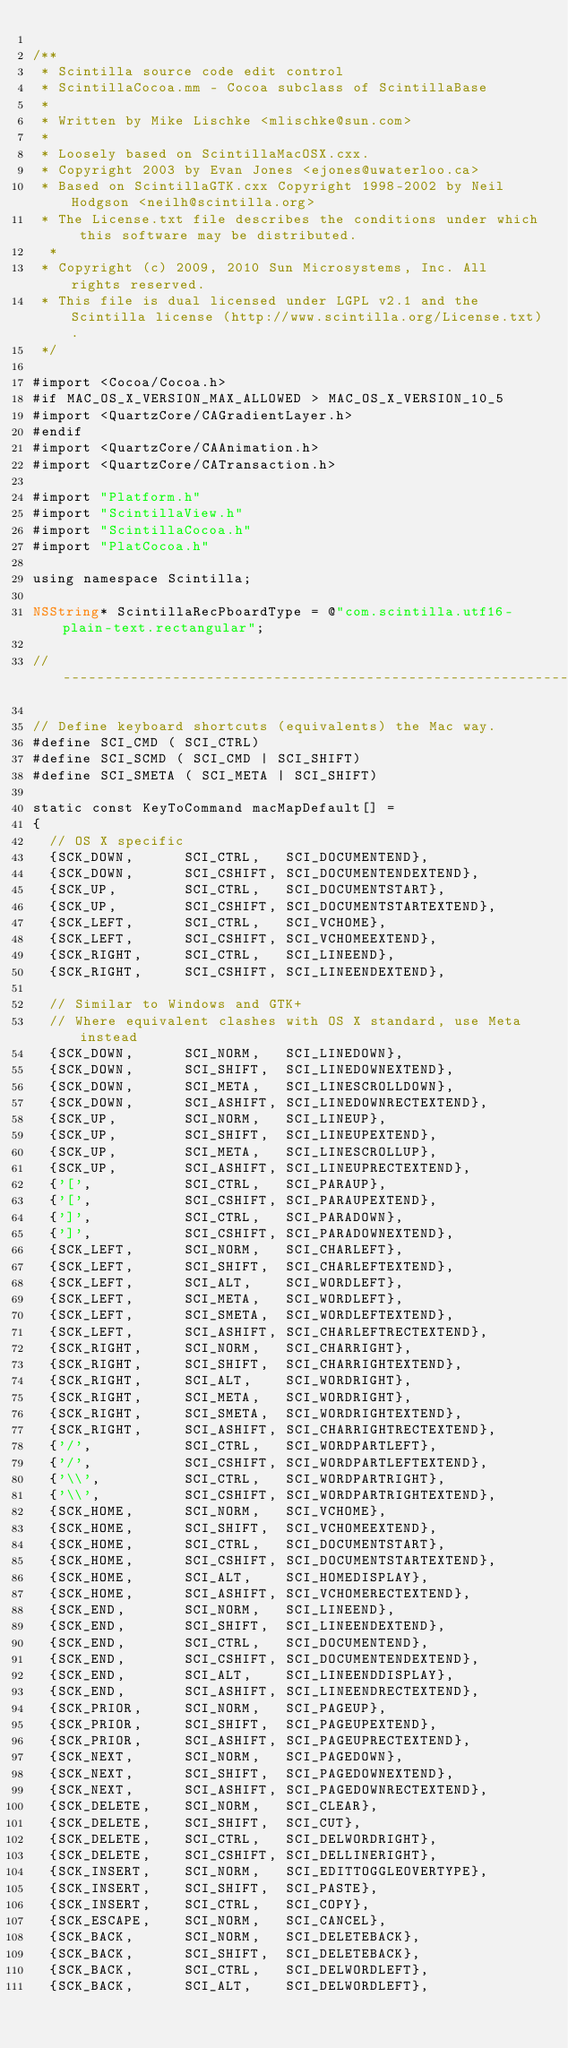<code> <loc_0><loc_0><loc_500><loc_500><_ObjectiveC_>
/**
 * Scintilla source code edit control
 * ScintillaCocoa.mm - Cocoa subclass of ScintillaBase
 *
 * Written by Mike Lischke <mlischke@sun.com>
 *
 * Loosely based on ScintillaMacOSX.cxx.
 * Copyright 2003 by Evan Jones <ejones@uwaterloo.ca>
 * Based on ScintillaGTK.cxx Copyright 1998-2002 by Neil Hodgson <neilh@scintilla.org>
 * The License.txt file describes the conditions under which this software may be distributed.
  *
 * Copyright (c) 2009, 2010 Sun Microsystems, Inc. All rights reserved.
 * This file is dual licensed under LGPL v2.1 and the Scintilla license (http://www.scintilla.org/License.txt).
 */

#import <Cocoa/Cocoa.h>
#if MAC_OS_X_VERSION_MAX_ALLOWED > MAC_OS_X_VERSION_10_5
#import <QuartzCore/CAGradientLayer.h>
#endif
#import <QuartzCore/CAAnimation.h>
#import <QuartzCore/CATransaction.h>

#import "Platform.h"
#import "ScintillaView.h"
#import "ScintillaCocoa.h"
#import "PlatCocoa.h"

using namespace Scintilla;

NSString* ScintillaRecPboardType = @"com.scintilla.utf16-plain-text.rectangular";

//--------------------------------------------------------------------------------------------------

// Define keyboard shortcuts (equivalents) the Mac way.
#define SCI_CMD ( SCI_CTRL)
#define SCI_SCMD ( SCI_CMD | SCI_SHIFT)
#define SCI_SMETA ( SCI_META | SCI_SHIFT)

static const KeyToCommand macMapDefault[] =
{
  // OS X specific
  {SCK_DOWN,      SCI_CTRL,   SCI_DOCUMENTEND},
  {SCK_DOWN,      SCI_CSHIFT, SCI_DOCUMENTENDEXTEND},
  {SCK_UP,        SCI_CTRL,   SCI_DOCUMENTSTART},
  {SCK_UP,        SCI_CSHIFT, SCI_DOCUMENTSTARTEXTEND},
  {SCK_LEFT,      SCI_CTRL,   SCI_VCHOME},
  {SCK_LEFT,      SCI_CSHIFT, SCI_VCHOMEEXTEND},
  {SCK_RIGHT,     SCI_CTRL,   SCI_LINEEND},
  {SCK_RIGHT,     SCI_CSHIFT, SCI_LINEENDEXTEND},

  // Similar to Windows and GTK+
  // Where equivalent clashes with OS X standard, use Meta instead
  {SCK_DOWN,      SCI_NORM,   SCI_LINEDOWN},
  {SCK_DOWN,      SCI_SHIFT,  SCI_LINEDOWNEXTEND},
  {SCK_DOWN,      SCI_META,   SCI_LINESCROLLDOWN},
  {SCK_DOWN,      SCI_ASHIFT, SCI_LINEDOWNRECTEXTEND},
  {SCK_UP,        SCI_NORM,   SCI_LINEUP},
  {SCK_UP,        SCI_SHIFT,  SCI_LINEUPEXTEND},
  {SCK_UP,        SCI_META,   SCI_LINESCROLLUP},
  {SCK_UP,        SCI_ASHIFT, SCI_LINEUPRECTEXTEND},
  {'[',           SCI_CTRL,   SCI_PARAUP},
  {'[',           SCI_CSHIFT, SCI_PARAUPEXTEND},
  {']',           SCI_CTRL,   SCI_PARADOWN},
  {']',           SCI_CSHIFT, SCI_PARADOWNEXTEND},
  {SCK_LEFT,      SCI_NORM,   SCI_CHARLEFT},
  {SCK_LEFT,      SCI_SHIFT,  SCI_CHARLEFTEXTEND},
  {SCK_LEFT,      SCI_ALT,    SCI_WORDLEFT},
  {SCK_LEFT,      SCI_META,   SCI_WORDLEFT},
  {SCK_LEFT,      SCI_SMETA,  SCI_WORDLEFTEXTEND},
  {SCK_LEFT,      SCI_ASHIFT, SCI_CHARLEFTRECTEXTEND},
  {SCK_RIGHT,     SCI_NORM,   SCI_CHARRIGHT},
  {SCK_RIGHT,     SCI_SHIFT,  SCI_CHARRIGHTEXTEND},
  {SCK_RIGHT,     SCI_ALT,    SCI_WORDRIGHT},
  {SCK_RIGHT,     SCI_META,   SCI_WORDRIGHT},
  {SCK_RIGHT,     SCI_SMETA,  SCI_WORDRIGHTEXTEND},
  {SCK_RIGHT,     SCI_ASHIFT, SCI_CHARRIGHTRECTEXTEND},
  {'/',           SCI_CTRL,   SCI_WORDPARTLEFT},
  {'/',           SCI_CSHIFT, SCI_WORDPARTLEFTEXTEND},
  {'\\',          SCI_CTRL,   SCI_WORDPARTRIGHT},
  {'\\',          SCI_CSHIFT, SCI_WORDPARTRIGHTEXTEND},
  {SCK_HOME,      SCI_NORM,   SCI_VCHOME},
  {SCK_HOME,      SCI_SHIFT,  SCI_VCHOMEEXTEND},
  {SCK_HOME,      SCI_CTRL,   SCI_DOCUMENTSTART},
  {SCK_HOME,      SCI_CSHIFT, SCI_DOCUMENTSTARTEXTEND},
  {SCK_HOME,      SCI_ALT,    SCI_HOMEDISPLAY},
  {SCK_HOME,      SCI_ASHIFT, SCI_VCHOMERECTEXTEND},
  {SCK_END,       SCI_NORM,   SCI_LINEEND},
  {SCK_END,       SCI_SHIFT,  SCI_LINEENDEXTEND},
  {SCK_END,       SCI_CTRL,   SCI_DOCUMENTEND},
  {SCK_END,       SCI_CSHIFT, SCI_DOCUMENTENDEXTEND},
  {SCK_END,       SCI_ALT,    SCI_LINEENDDISPLAY},
  {SCK_END,       SCI_ASHIFT, SCI_LINEENDRECTEXTEND},
  {SCK_PRIOR,     SCI_NORM,   SCI_PAGEUP},
  {SCK_PRIOR,     SCI_SHIFT,  SCI_PAGEUPEXTEND},
  {SCK_PRIOR,     SCI_ASHIFT, SCI_PAGEUPRECTEXTEND},
  {SCK_NEXT,      SCI_NORM,   SCI_PAGEDOWN},
  {SCK_NEXT,      SCI_SHIFT,  SCI_PAGEDOWNEXTEND},
  {SCK_NEXT,      SCI_ASHIFT, SCI_PAGEDOWNRECTEXTEND},
  {SCK_DELETE,    SCI_NORM,   SCI_CLEAR},
  {SCK_DELETE,    SCI_SHIFT,  SCI_CUT},
  {SCK_DELETE,    SCI_CTRL,   SCI_DELWORDRIGHT},
  {SCK_DELETE,    SCI_CSHIFT, SCI_DELLINERIGHT},
  {SCK_INSERT,    SCI_NORM,   SCI_EDITTOGGLEOVERTYPE},
  {SCK_INSERT,    SCI_SHIFT,  SCI_PASTE},
  {SCK_INSERT,    SCI_CTRL,   SCI_COPY},
  {SCK_ESCAPE,    SCI_NORM,   SCI_CANCEL},
  {SCK_BACK,      SCI_NORM,   SCI_DELETEBACK},
  {SCK_BACK,      SCI_SHIFT,  SCI_DELETEBACK},
  {SCK_BACK,      SCI_CTRL,   SCI_DELWORDLEFT},
  {SCK_BACK,      SCI_ALT,    SCI_DELWORDLEFT},</code> 